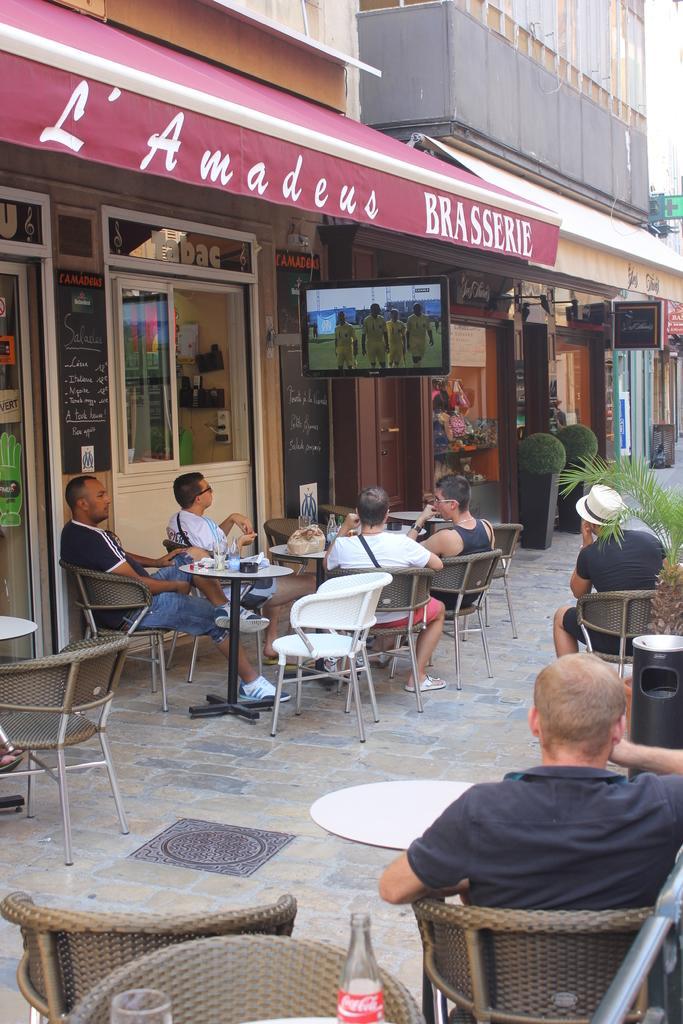Could you give a brief overview of what you see in this image? In this image I can see 6 men sitting on the chairs and I can also see there are lot of tables in front of them and there is a screen in front and there are lot of shops and few plants over here. I can also there are few chairs over here and a bottle, a glass and 2 buildings. 